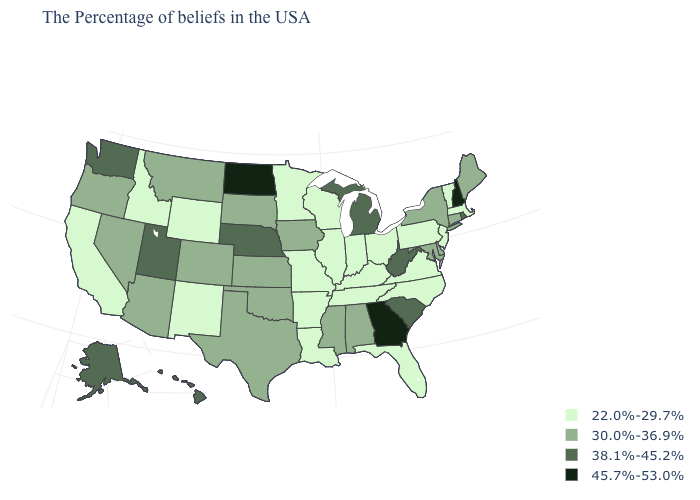What is the value of Alaska?
Be succinct. 38.1%-45.2%. What is the value of New York?
Keep it brief. 30.0%-36.9%. Name the states that have a value in the range 30.0%-36.9%?
Short answer required. Maine, Connecticut, New York, Delaware, Maryland, Alabama, Mississippi, Iowa, Kansas, Oklahoma, Texas, South Dakota, Colorado, Montana, Arizona, Nevada, Oregon. Does Virginia have the lowest value in the South?
Be succinct. Yes. What is the value of North Carolina?
Give a very brief answer. 22.0%-29.7%. Does Vermont have the lowest value in the USA?
Quick response, please. Yes. What is the highest value in states that border North Carolina?
Answer briefly. 45.7%-53.0%. Among the states that border Tennessee , which have the highest value?
Keep it brief. Georgia. What is the lowest value in the South?
Keep it brief. 22.0%-29.7%. Which states have the lowest value in the Northeast?
Keep it brief. Massachusetts, Vermont, New Jersey, Pennsylvania. Name the states that have a value in the range 22.0%-29.7%?
Short answer required. Massachusetts, Vermont, New Jersey, Pennsylvania, Virginia, North Carolina, Ohio, Florida, Kentucky, Indiana, Tennessee, Wisconsin, Illinois, Louisiana, Missouri, Arkansas, Minnesota, Wyoming, New Mexico, Idaho, California. Name the states that have a value in the range 22.0%-29.7%?
Short answer required. Massachusetts, Vermont, New Jersey, Pennsylvania, Virginia, North Carolina, Ohio, Florida, Kentucky, Indiana, Tennessee, Wisconsin, Illinois, Louisiana, Missouri, Arkansas, Minnesota, Wyoming, New Mexico, Idaho, California. Name the states that have a value in the range 45.7%-53.0%?
Short answer required. New Hampshire, Georgia, North Dakota. Name the states that have a value in the range 30.0%-36.9%?
Quick response, please. Maine, Connecticut, New York, Delaware, Maryland, Alabama, Mississippi, Iowa, Kansas, Oklahoma, Texas, South Dakota, Colorado, Montana, Arizona, Nevada, Oregon. What is the lowest value in states that border Georgia?
Be succinct. 22.0%-29.7%. 